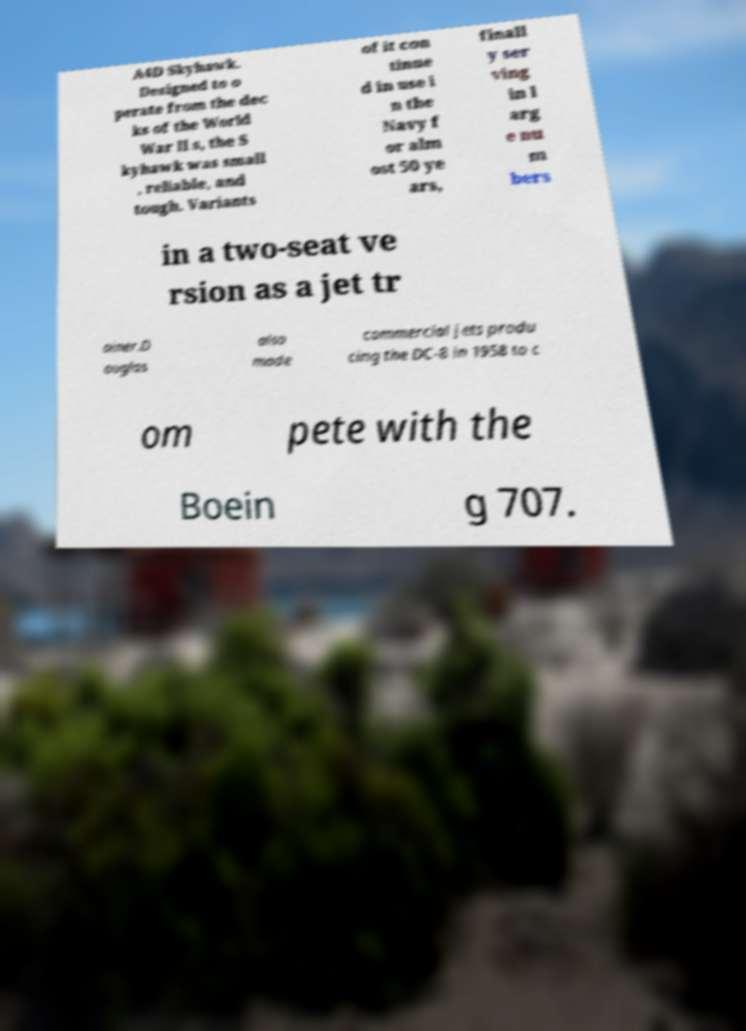Please identify and transcribe the text found in this image. A4D Skyhawk. Designed to o perate from the dec ks of the World War II s, the S kyhawk was small , reliable, and tough. Variants of it con tinue d in use i n the Navy f or alm ost 50 ye ars, finall y ser ving in l arg e nu m bers in a two-seat ve rsion as a jet tr ainer.D ouglas also made commercial jets produ cing the DC-8 in 1958 to c om pete with the Boein g 707. 